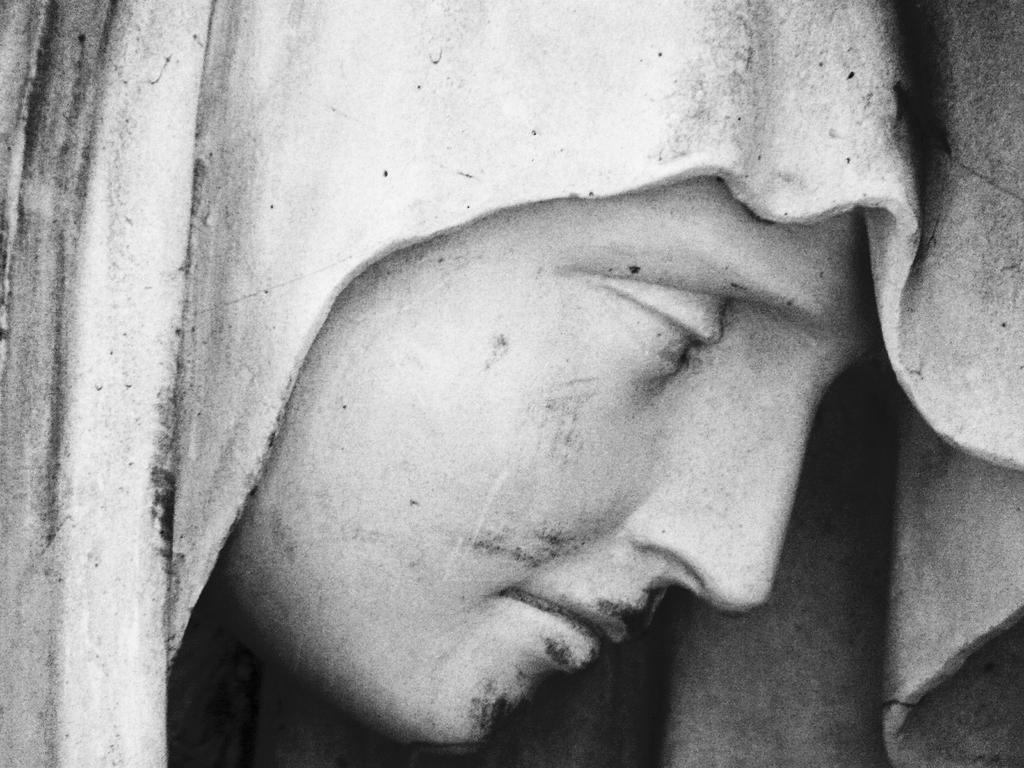Please provide a concise description of this image. In this image there is a sculpture of a person's face. 